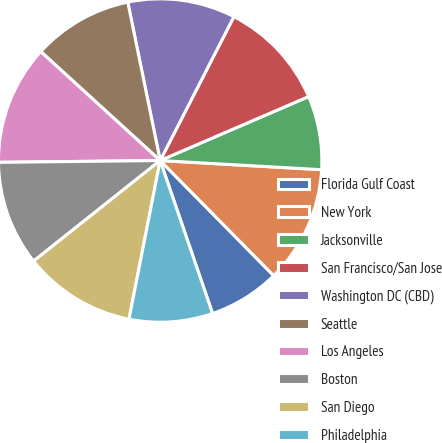Convert chart. <chart><loc_0><loc_0><loc_500><loc_500><pie_chart><fcel>Florida Gulf Coast<fcel>New York<fcel>Jacksonville<fcel>San Francisco/San Jose<fcel>Washington DC (CBD)<fcel>Seattle<fcel>Los Angeles<fcel>Boston<fcel>San Diego<fcel>Philadelphia<nl><fcel>7.14%<fcel>11.71%<fcel>7.38%<fcel>10.99%<fcel>10.75%<fcel>10.02%<fcel>11.95%<fcel>10.51%<fcel>11.23%<fcel>8.34%<nl></chart> 